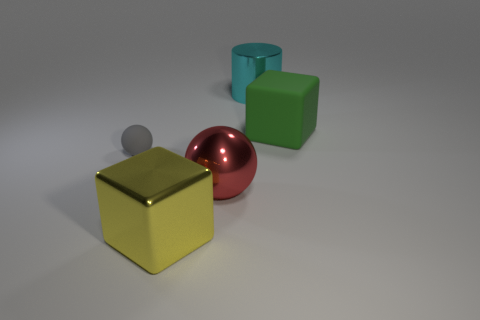There is a matte thing that is to the left of the large metallic cylinder; is its shape the same as the large shiny object that is in front of the big red metallic sphere?
Make the answer very short. No. What material is the green block?
Provide a succinct answer. Rubber. What number of green things have the same size as the gray matte ball?
Offer a very short reply. 0. How many objects are metal things on the left side of the red ball or things that are in front of the cylinder?
Your answer should be compact. 4. Are the large cube that is right of the large red sphere and the cube in front of the big green cube made of the same material?
Offer a terse response. No. What is the shape of the rubber thing that is on the right side of the big cube that is in front of the large matte object?
Make the answer very short. Cube. Is there anything else that has the same color as the rubber ball?
Your answer should be very brief. No. Are there any yellow cubes behind the rubber thing right of the shiny object on the right side of the large red thing?
Your response must be concise. No. What is the material of the cylinder that is the same size as the yellow metallic object?
Offer a terse response. Metal. What size is the metallic thing to the right of the ball to the right of the big thing in front of the large red thing?
Offer a very short reply. Large. 